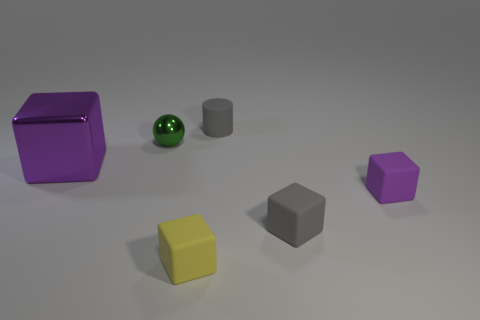Subtract all brown cubes. Subtract all cyan balls. How many cubes are left? 4 Add 2 purple matte things. How many objects exist? 8 Subtract all spheres. How many objects are left? 5 Add 3 large purple things. How many large purple things are left? 4 Add 4 tiny objects. How many tiny objects exist? 9 Subtract 0 red balls. How many objects are left? 6 Subtract all small gray rubber things. Subtract all big purple metallic things. How many objects are left? 3 